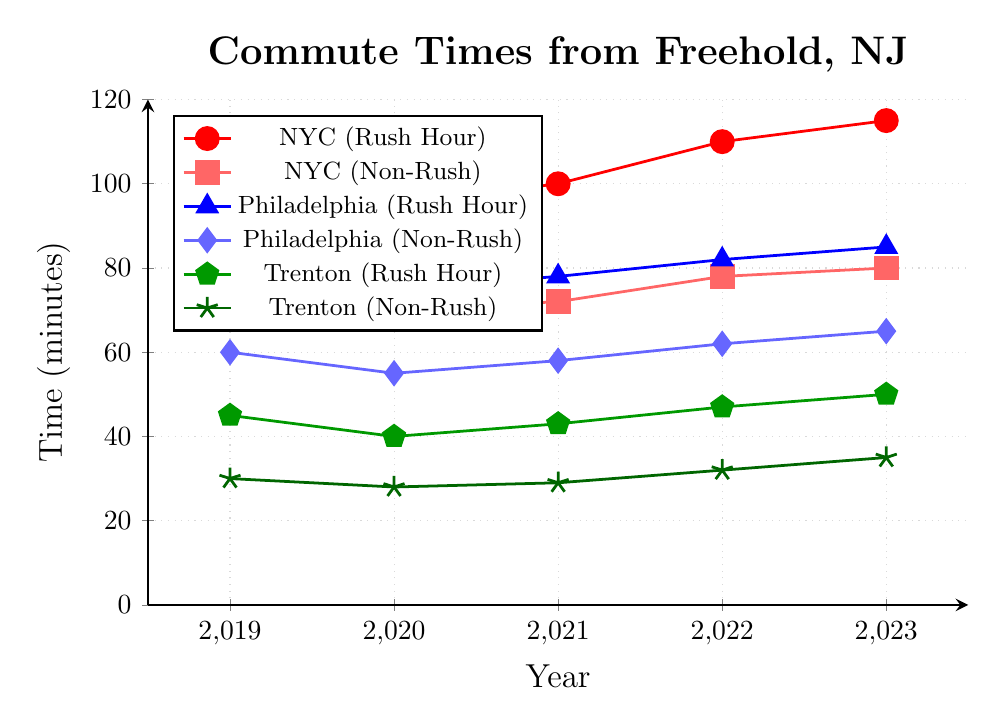What year had the longest rush hour commute to New York City? By looking at the 'NYC (Rush Hour)' line (red with circle markers), we see that the highest point occurs in 2023.
Answer: 2023 Did the rush hour commutes to Philadelphia and Trenton increase every year? Look at the lines for 'Philadelphia (Rush Hour)' (blue with triangle markers) and 'Trenton (Rush Hour)' (green with pentagon markers). Both lines show an upward trend each year, indicating increases each year.
Answer: Yes Which city's non-rush hour commute time increased the most from 2019 to 2023? Calculate the differences for non-rush times from 2019 to 2023 for each city: NYC (80-75=5), Philadelphia (65-60=5), and Trenton (35-30=5). All cities' non-rush times increased equally by 5 minutes.
Answer: All equal (5 minutes each) How much did the rush hour commute time to New York City increase from 2021 to 2023? Subtract the 2021 value from the 2023 value for 'NYC (Rush Hour)'. (115 - 100 = 15)
Answer: 15 minutes What is the shortest commute time recorded in the given data set? Look at the lowest points of all lines. The shortest time is from 'Trenton (Non-Rush)' in 2020, which is 28 minutes.
Answer: 28 minutes Compare the rush hour commute times to New York City and Philadelphia in 2022. Which city has a longer commute and by how much? Identify points on the lines for 'NYC (Rush Hour)' and 'Philadelphia (Rush Hour)' in 2022. NYC has 110 minutes, Philadelphia has 82 minutes, so 110 - 82 = 28 minutes longer.
Answer: New York City by 28 minutes What's the average non-rush hour commute time to Trenton over the five years? Add all 'Trenton (Non-Rush)' times: (30 + 28 + 29 + 32 + 35) = 154 and divide by 5, which gives 154 / 5 = 30.8
Answer: 30.8 minutes Which city had the smallest increase in rush hour commute time from 2019 to 2023? Calculate differences for 'Rush Hour' times from 2019 to 2023: NYC (115-105=10), Philadelphia (85-80=5), Trenton (50-45=5). Philadelphia and Trenton both have the smallest increase of 5 minutes.
Answer: Philadelphia and Trenton What's the difference between rush hour and non-rush hour commute times to New York City in 2023? Subtract the non-rush hour time from the rush hour time for NYC in 2023: (115 - 80) = 35 minutes
Answer: 35 minutes 